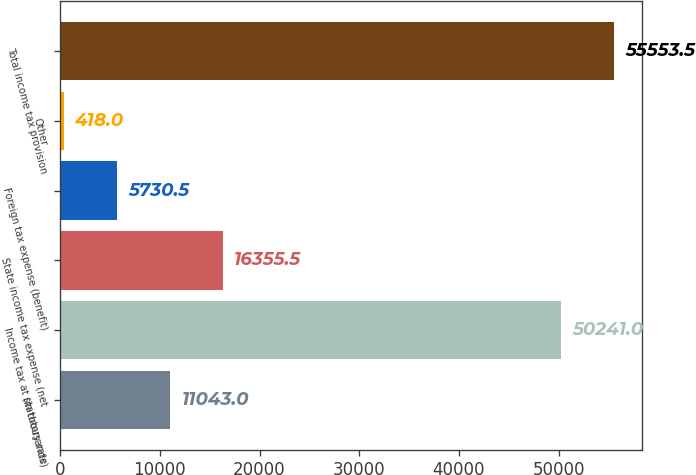Convert chart to OTSL. <chart><loc_0><loc_0><loc_500><loc_500><bar_chart><fcel>(in thousands)<fcel>Income tax at statutory rate<fcel>State income tax expense (net<fcel>Foreign tax expense (benefit)<fcel>Other<fcel>Total income tax provision<nl><fcel>11043<fcel>50241<fcel>16355.5<fcel>5730.5<fcel>418<fcel>55553.5<nl></chart> 